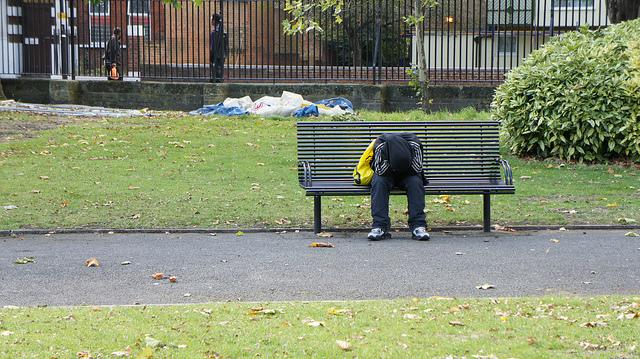Where were the first free public benches invented? paris 